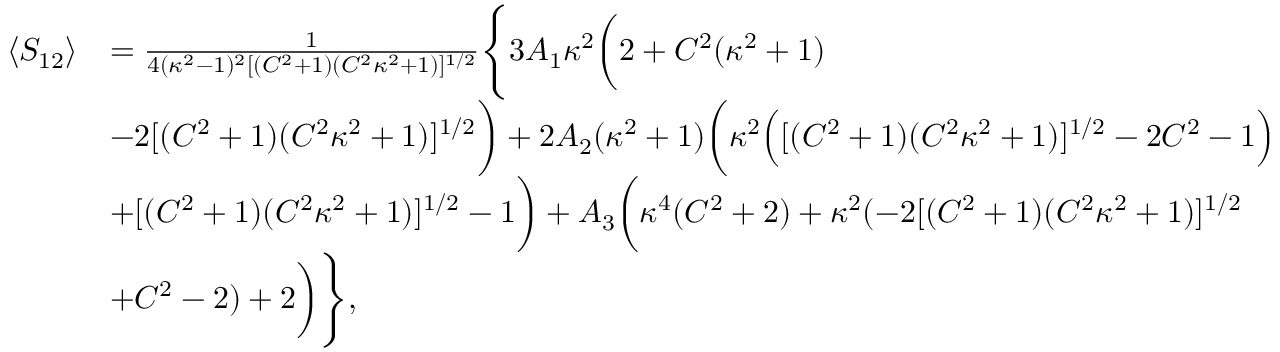<formula> <loc_0><loc_0><loc_500><loc_500>\begin{array} { r l } { \langle S _ { 1 2 } \rangle } & { = \frac { 1 } { 4 ( \kappa ^ { 2 } - 1 ) ^ { 2 } [ ( C ^ { 2 } + 1 ) ( C ^ { 2 } \kappa ^ { 2 } + 1 ) ] ^ { 1 / 2 } } \left \{ 3 A _ { 1 } \kappa ^ { 2 } \left ( 2 + C ^ { 2 } ( \kappa ^ { 2 } + 1 ) } \\ & { - 2 [ ( C ^ { 2 } + 1 ) ( C ^ { 2 } \kappa ^ { 2 } + 1 ) ] ^ { 1 / 2 } \right ) + 2 A _ { 2 } ( \kappa ^ { 2 } + 1 ) \left ( \kappa ^ { 2 } \left ( [ ( C ^ { 2 } + 1 ) ( C ^ { 2 } \kappa ^ { 2 } + 1 ) ] ^ { 1 / 2 } - 2 C ^ { 2 } - 1 \right ) } \\ & { + [ ( C ^ { 2 } + 1 ) ( C ^ { 2 } \kappa ^ { 2 } + 1 ) ] ^ { 1 / 2 } - 1 \right ) + A _ { 3 } \left ( \kappa ^ { 4 } ( C ^ { 2 } + 2 ) + \kappa ^ { 2 } ( - 2 [ ( C ^ { 2 } + 1 ) ( C ^ { 2 } \kappa ^ { 2 } + 1 ) ] ^ { 1 / 2 } } \\ & { + C ^ { 2 } - 2 ) + 2 \right ) \right \} , } \end{array}</formula> 